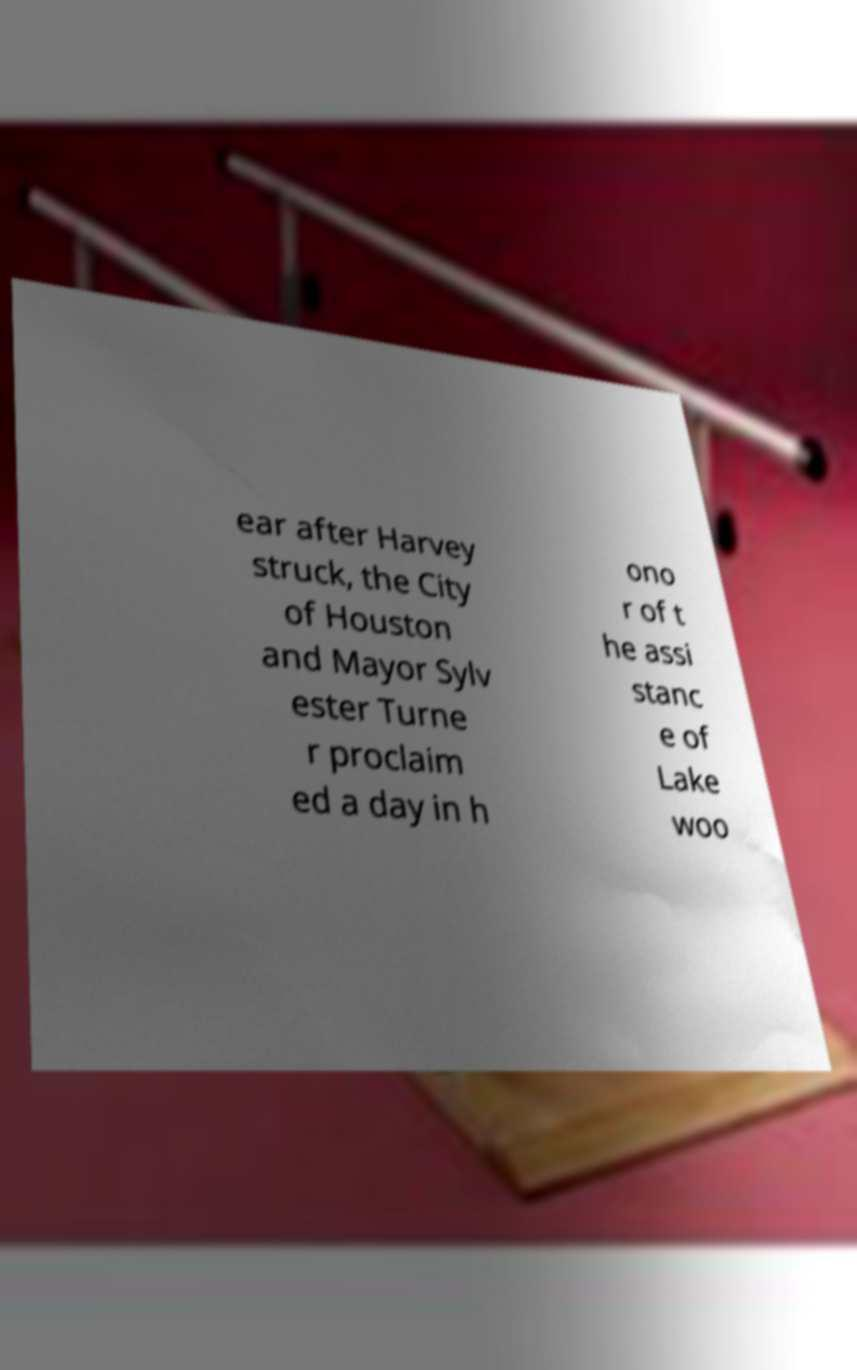Could you extract and type out the text from this image? ear after Harvey struck, the City of Houston and Mayor Sylv ester Turne r proclaim ed a day in h ono r of t he assi stanc e of Lake woo 